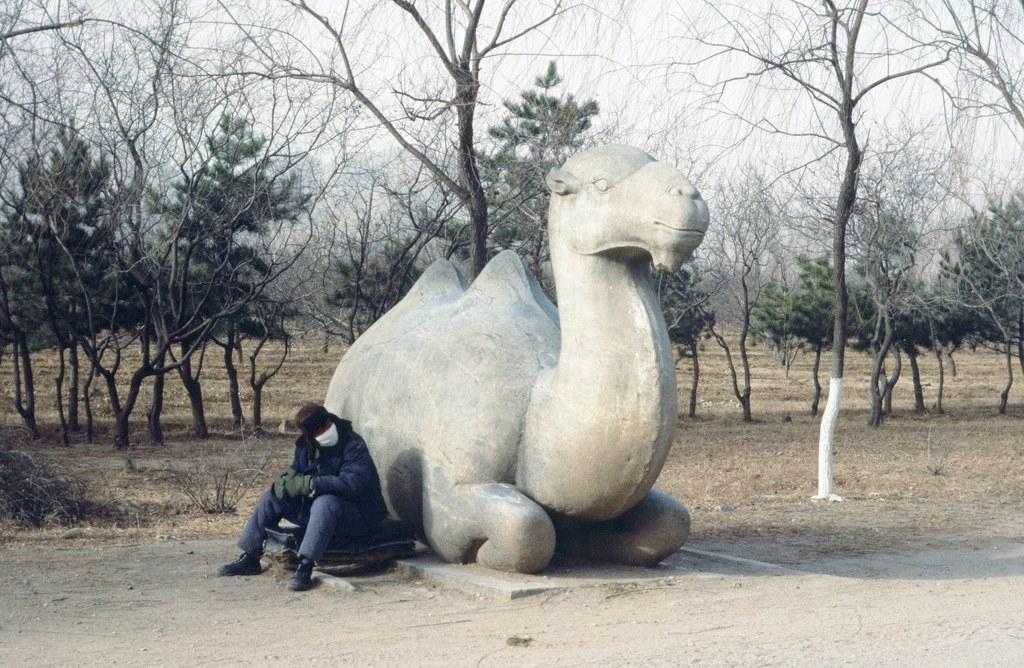How would you summarize this image in a sentence or two? In this image I can see a statue of a camel. Here I can see a person is sitting. In the background I can see trees, the grass and the sky. 